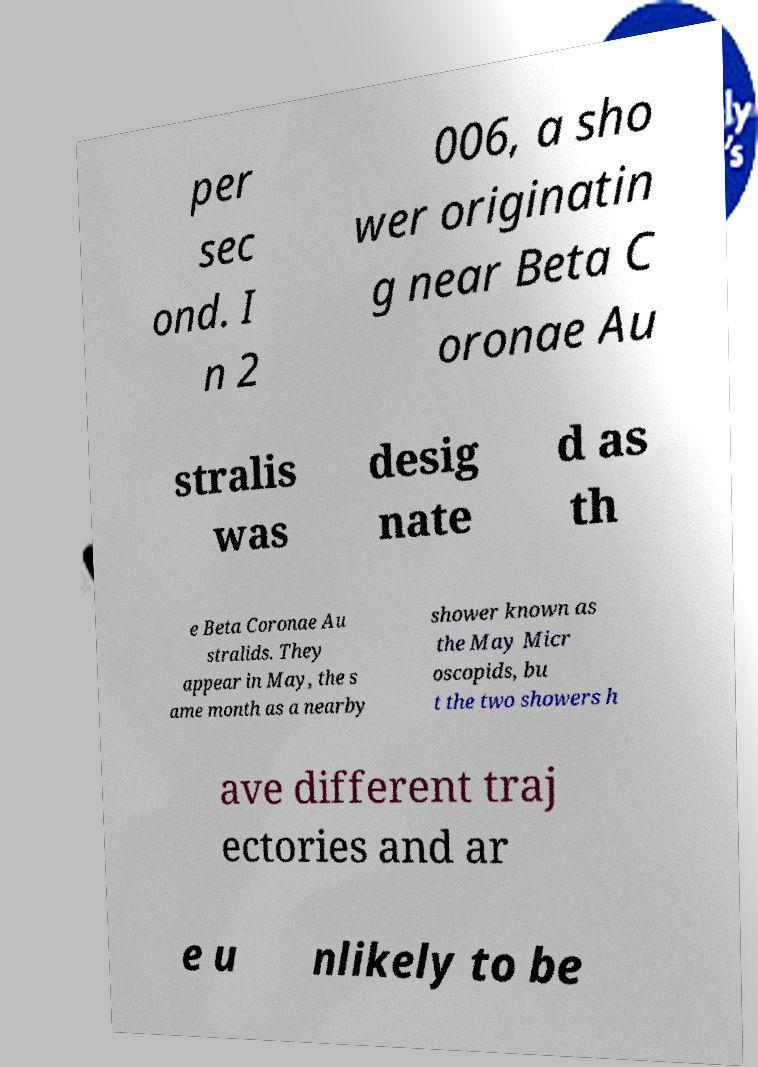Can you accurately transcribe the text from the provided image for me? per sec ond. I n 2 006, a sho wer originatin g near Beta C oronae Au stralis was desig nate d as th e Beta Coronae Au stralids. They appear in May, the s ame month as a nearby shower known as the May Micr oscopids, bu t the two showers h ave different traj ectories and ar e u nlikely to be 